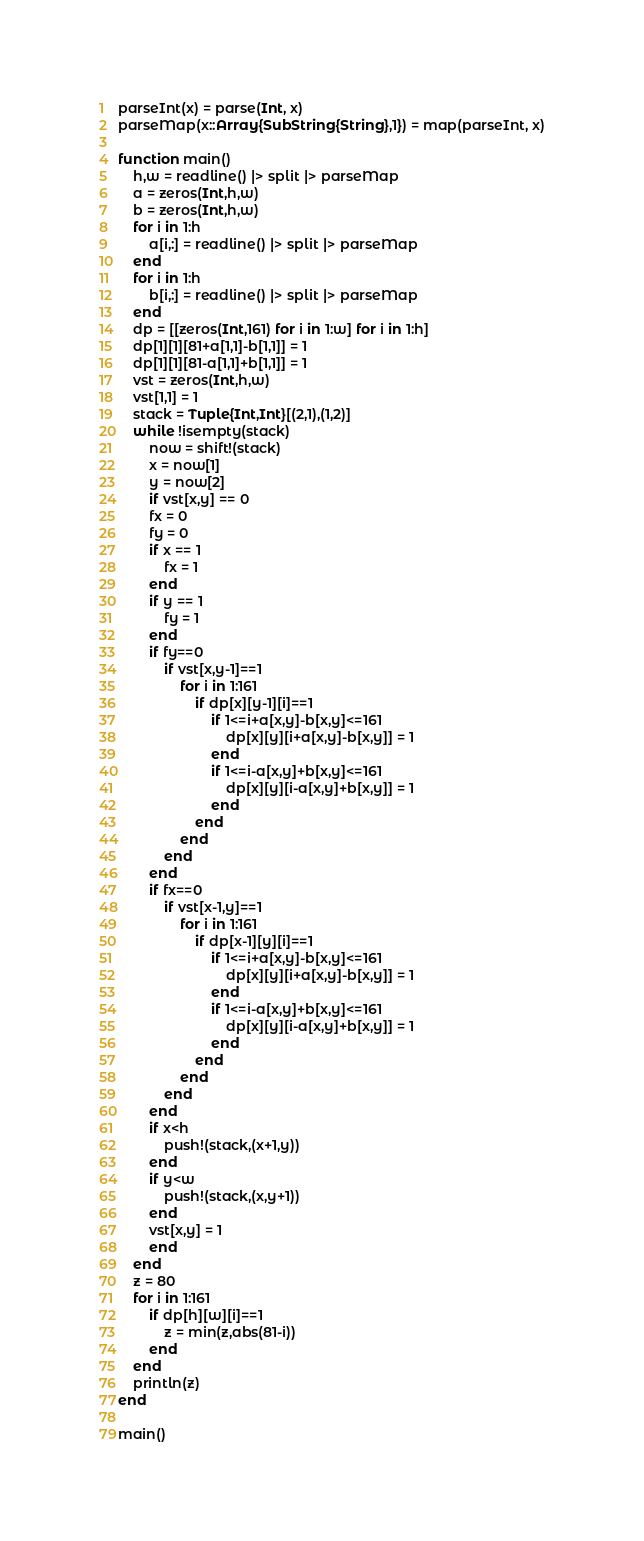Convert code to text. <code><loc_0><loc_0><loc_500><loc_500><_Julia_>parseInt(x) = parse(Int, x)
parseMap(x::Array{SubString{String},1}) = map(parseInt, x)

function main()
	h,w = readline() |> split |> parseMap
	a = zeros(Int,h,w)
	b = zeros(Int,h,w)
	for i in 1:h
		a[i,:] = readline() |> split |> parseMap
	end
	for i in 1:h
		b[i,:] = readline() |> split |> parseMap
	end
	dp = [[zeros(Int,161) for i in 1:w] for i in 1:h]
	dp[1][1][81+a[1,1]-b[1,1]] = 1
	dp[1][1][81-a[1,1]+b[1,1]] = 1
	vst = zeros(Int,h,w)
	vst[1,1] = 1
	stack = Tuple{Int,Int}[(2,1),(1,2)]
	while !isempty(stack)
		now = shift!(stack)
		x = now[1]
		y = now[2]
		if vst[x,y] == 0
		fx = 0
		fy = 0
		if x == 1
			fx = 1
		end
		if y == 1
			fy = 1
		end
		if fy==0
			if vst[x,y-1]==1
				for i in 1:161
					if dp[x][y-1][i]==1
						if 1<=i+a[x,y]-b[x,y]<=161
							dp[x][y][i+a[x,y]-b[x,y]] = 1
						end
						if 1<=i-a[x,y]+b[x,y]<=161
							dp[x][y][i-a[x,y]+b[x,y]] = 1
						end
					end
				end
			end
		end
		if fx==0
			if vst[x-1,y]==1
				for i in 1:161
					if dp[x-1][y][i]==1
						if 1<=i+a[x,y]-b[x,y]<=161
							dp[x][y][i+a[x,y]-b[x,y]] = 1
						end
						if 1<=i-a[x,y]+b[x,y]<=161
							dp[x][y][i-a[x,y]+b[x,y]] = 1
						end
					end
				end
			end
		end
		if x<h
			push!(stack,(x+1,y))
		end
		if y<w
			push!(stack,(x,y+1))
		end
		vst[x,y] = 1
		end
	end
	z = 80
	for i in 1:161
		if dp[h][w][i]==1
			z = min(z,abs(81-i))
		end
	end
	println(z)
end

main()

</code> 